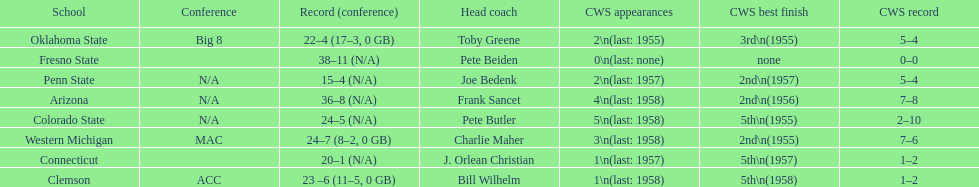Does clemson or western michigan have more cws appearances? Western Michigan. 